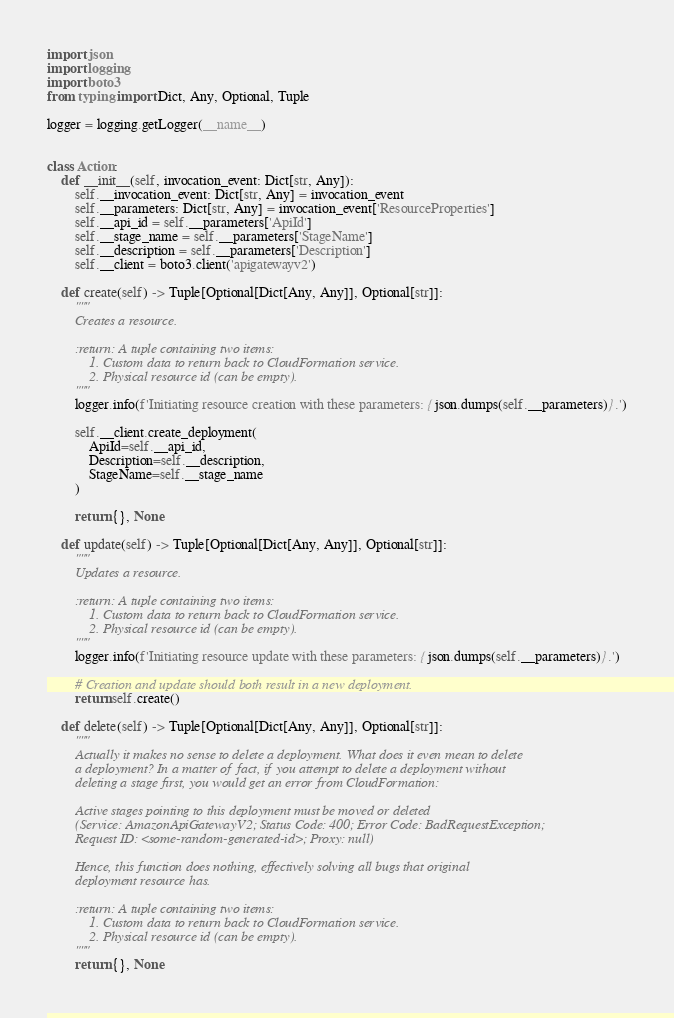Convert code to text. <code><loc_0><loc_0><loc_500><loc_500><_Python_>import json
import logging
import boto3
from typing import Dict, Any, Optional, Tuple

logger = logging.getLogger(__name__)


class Action:
    def __init__(self, invocation_event: Dict[str, Any]):
        self.__invocation_event: Dict[str, Any] = invocation_event
        self.__parameters: Dict[str, Any] = invocation_event['ResourceProperties']
        self.__api_id = self.__parameters['ApiId']
        self.__stage_name = self.__parameters['StageName']
        self.__description = self.__parameters['Description']
        self.__client = boto3.client('apigatewayv2')

    def create(self) -> Tuple[Optional[Dict[Any, Any]], Optional[str]]:
        """
        Creates a resource.

        :return: A tuple containing two items:
            1. Custom data to return back to CloudFormation service.
            2. Physical resource id (can be empty).
        """
        logger.info(f'Initiating resource creation with these parameters: {json.dumps(self.__parameters)}.')

        self.__client.create_deployment(
            ApiId=self.__api_id,
            Description=self.__description,
            StageName=self.__stage_name
        )

        return {}, None

    def update(self) -> Tuple[Optional[Dict[Any, Any]], Optional[str]]:
        """
        Updates a resource.

        :return: A tuple containing two items:
            1. Custom data to return back to CloudFormation service.
            2. Physical resource id (can be empty).
        """
        logger.info(f'Initiating resource update with these parameters: {json.dumps(self.__parameters)}.')

        # Creation and update should both result in a new deployment.
        return self.create()

    def delete(self) -> Tuple[Optional[Dict[Any, Any]], Optional[str]]:
        """
        Actually it makes no sense to delete a deployment. What does it even mean to delete
        a deployment? In a matter of fact, if you attempt to delete a deployment without
        deleting a stage first, you would get an error from CloudFormation:

        Active stages pointing to this deployment must be moved or deleted
        (Service: AmazonApiGatewayV2; Status Code: 400; Error Code: BadRequestException;
        Request ID: <some-random-generated-id>; Proxy: null)

        Hence, this function does nothing, effectively solving all bugs that original
        deployment resource has.

        :return: A tuple containing two items:
            1. Custom data to return back to CloudFormation service.
            2. Physical resource id (can be empty).
        """
        return {}, None
</code> 